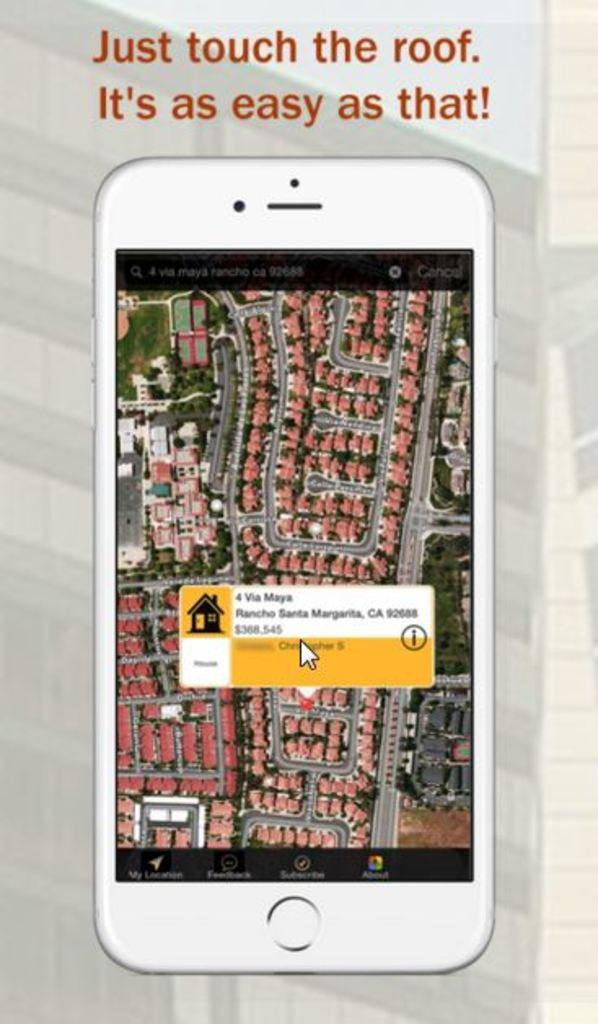<image>
Share a concise interpretation of the image provided. A phone has the slogan Just Touch the Roof written over it. 